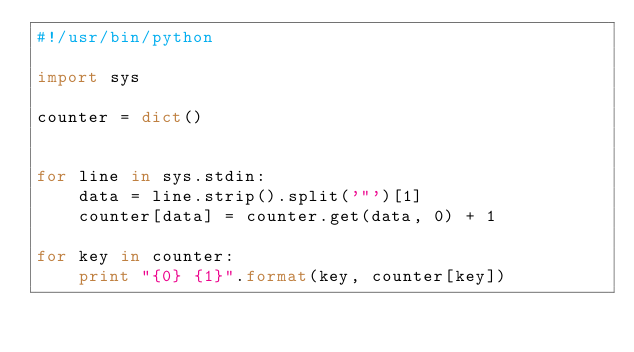Convert code to text. <code><loc_0><loc_0><loc_500><loc_500><_Python_>#!/usr/bin/python

import sys

counter = dict()


for line in sys.stdin:
    data = line.strip().split('"')[1]
    counter[data] = counter.get(data, 0) + 1

for key in counter:
    print "{0} {1}".format(key, counter[key])

    
</code> 